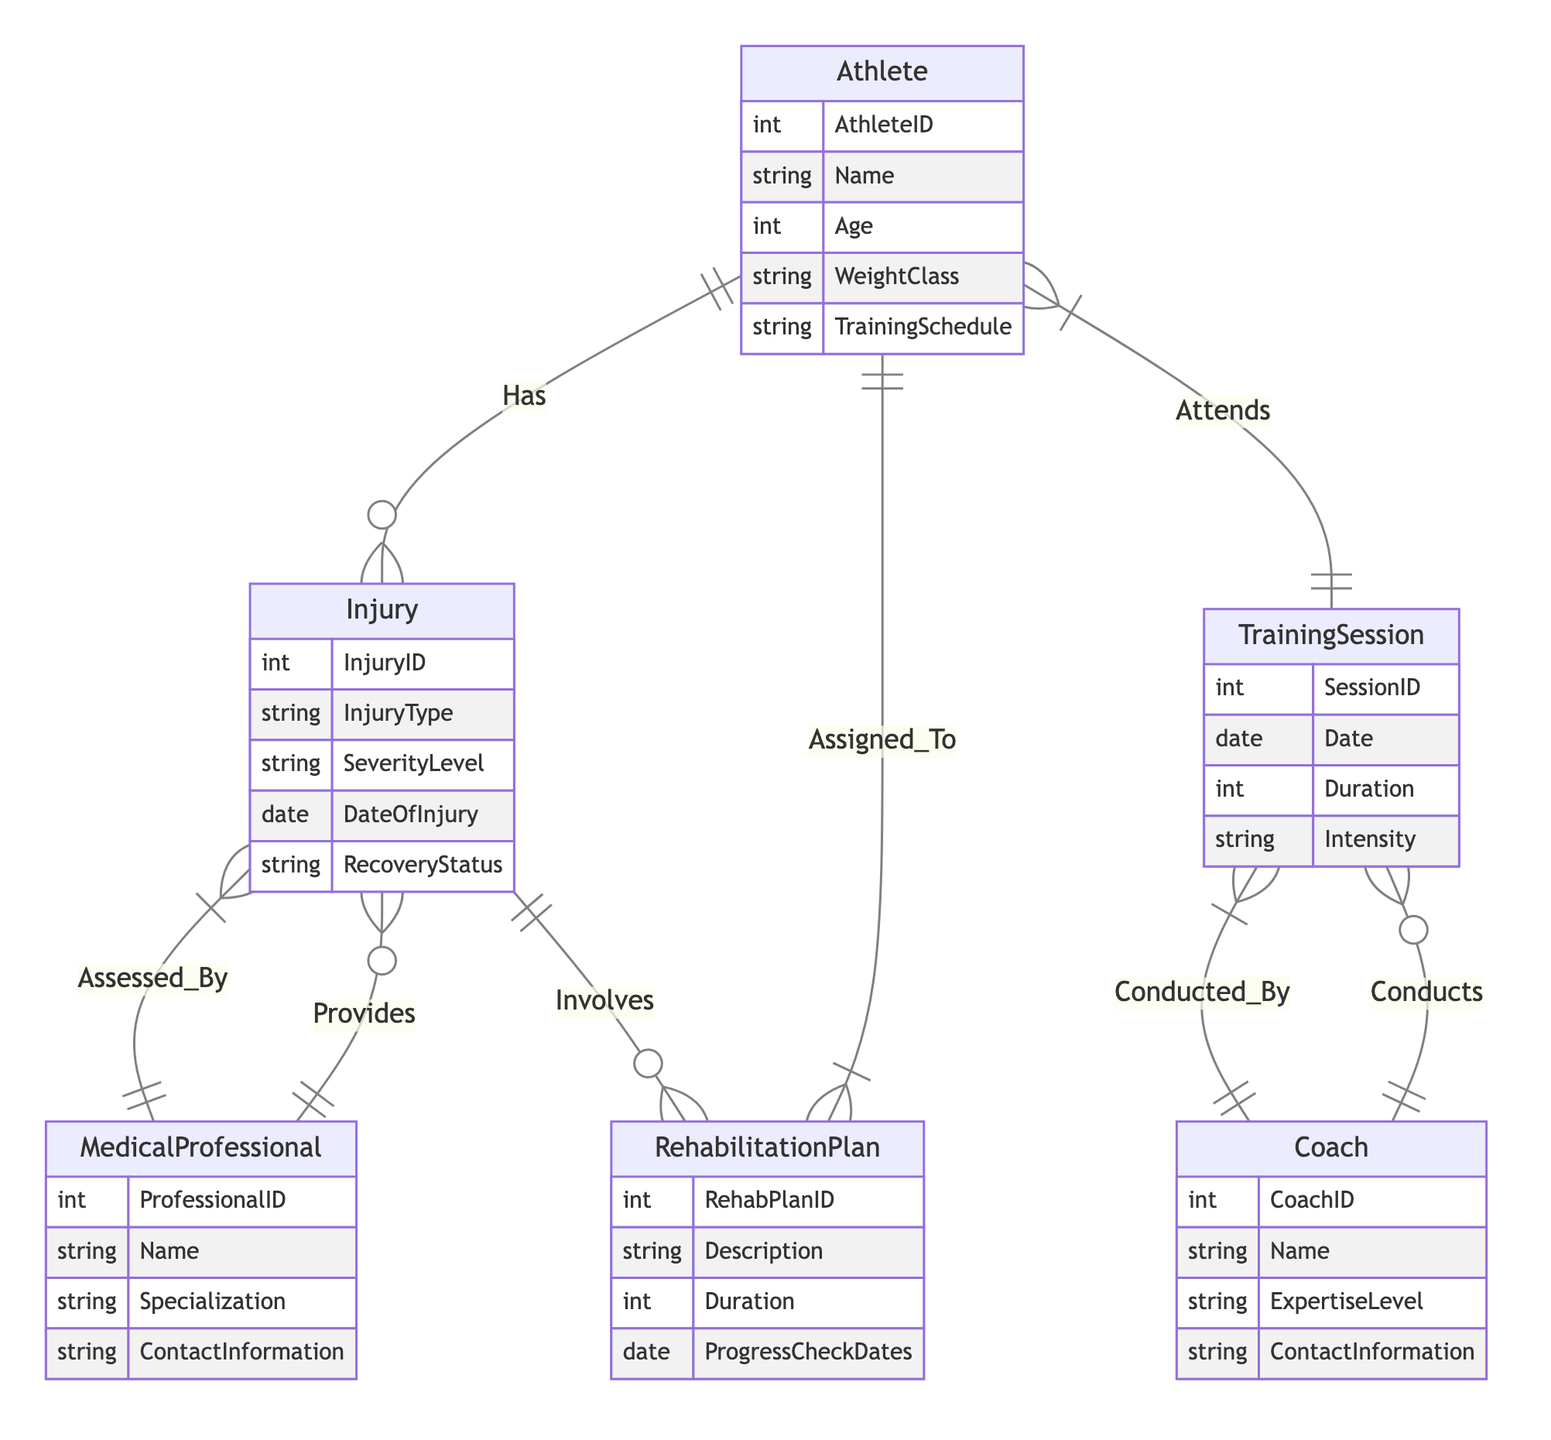What is the cardinality between Athlete and Injury? The diagram shows that an Athlete has a "1 to Many" relationship with Injury, indicating that one athlete can sustain multiple injuries.
Answer: 1 to Many How many attributes does the MedicalProfessional entity have? The MedicalProfessional entity has four attributes: ProfessionalID, Name, Specialization, and ContactInformation.
Answer: 4 Which entity is involved in assessing an Injury? The diagram indicates that an Injury is assessed by a MedicalProfessional, as represented by the "Assessed_By" relationship.
Answer: MedicalProfessional What type of relationship exists between RehabilitationPlan and Athlete? The RehabilitationPlan is assigned to an Athlete in a "Many to 1" relationship, showing that multiple rehabilitation plans can be assigned to one athlete.
Answer: Many to 1 Can a Coach conduct multiple TrainingSessions? Yes, according to the diagram, a Coach can conduct many TrainingSessions, which is reflected in the "Conducts" relationship.
Answer: Yes What is the maximum number of Injuries an Athlete can have? Since the diagram states that an Athlete has a "1 to Many" relationship with Injury, there is no specific limit indicated, meaning the number could be any number greater than or equal to one.
Answer: Many Which entity has the attribute 'SeverityLevel'? The attribute 'SeverityLevel' belongs to the Injury entity, indicating the injury's severity classification.
Answer: Injury What is the common relationship between TrainingSession and Coach? The TrainingSession is conducted by a Coach, establishing a "1 to Many" relationship, meaning a coach can conduct multiple training sessions.
Answer: Conducted_By What does the 'Involves' relationship represent between Injury and RehabilitationPlan? The relationship 'Involves' signifies that each Injury is associated with one or more RehabilitationPlans which are necessary for recovery.
Answer: Involves 